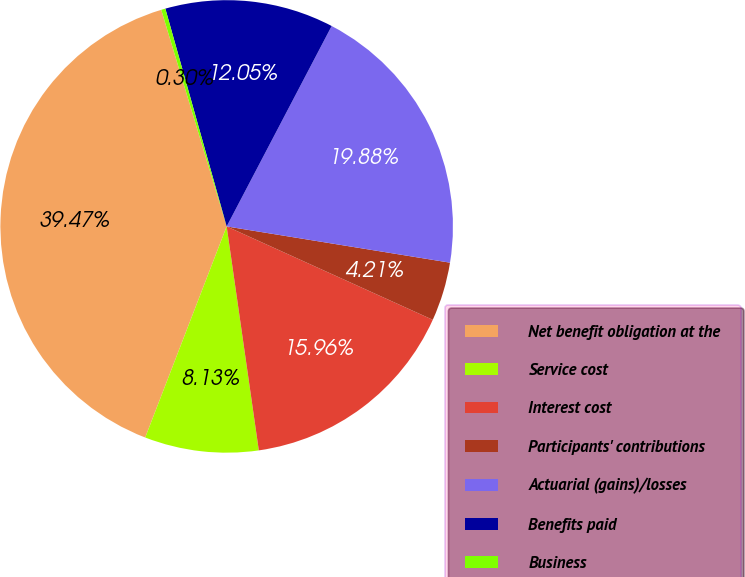Convert chart to OTSL. <chart><loc_0><loc_0><loc_500><loc_500><pie_chart><fcel>Net benefit obligation at the<fcel>Service cost<fcel>Interest cost<fcel>Participants' contributions<fcel>Actuarial (gains)/losses<fcel>Benefits paid<fcel>Business<nl><fcel>39.47%<fcel>8.13%<fcel>15.96%<fcel>4.21%<fcel>19.88%<fcel>12.05%<fcel>0.3%<nl></chart> 